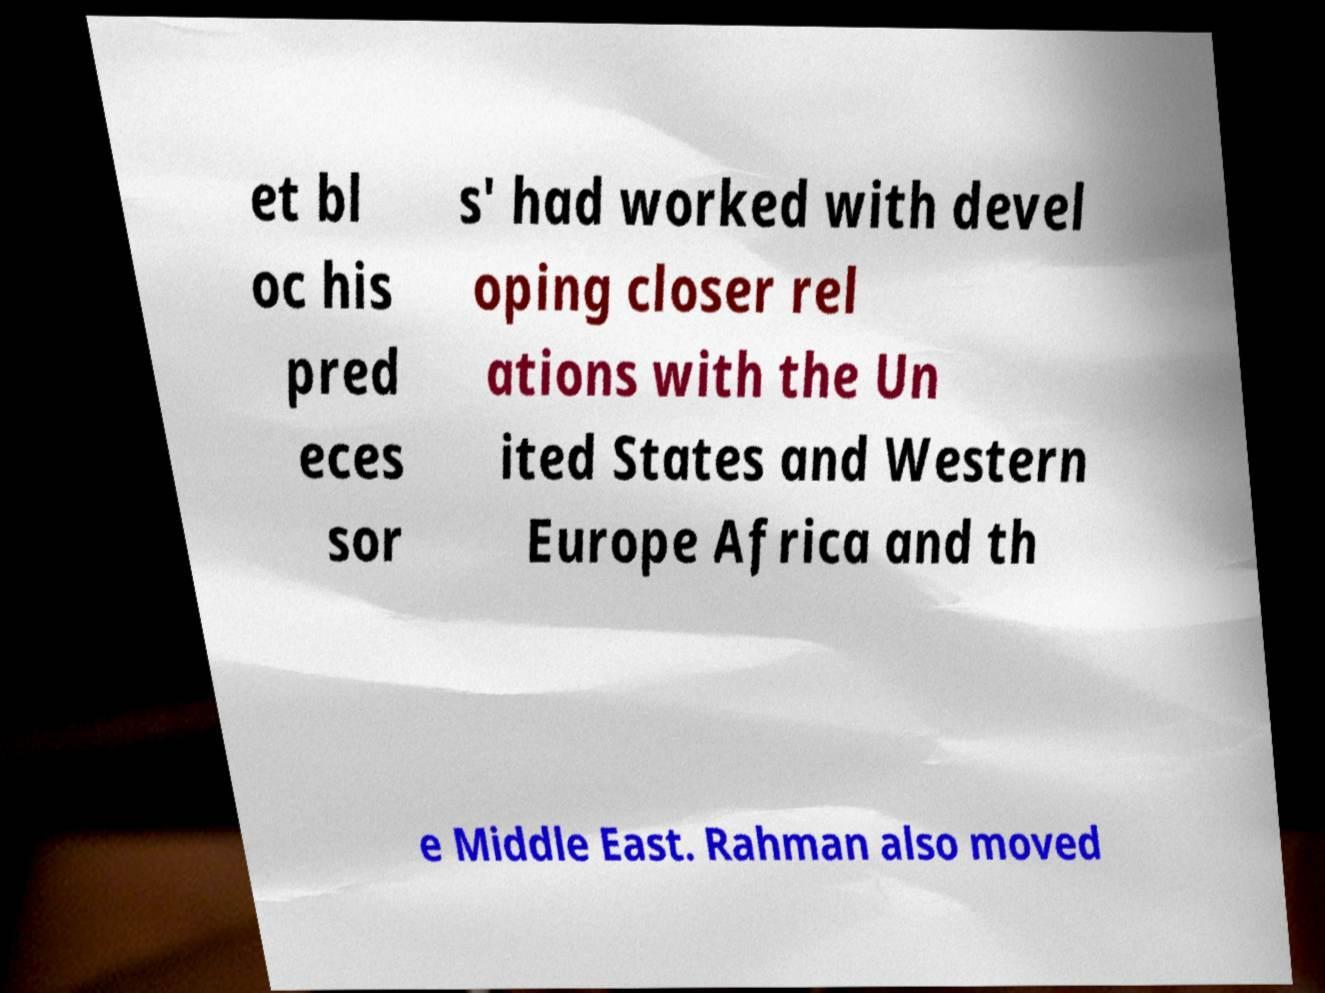What messages or text are displayed in this image? I need them in a readable, typed format. et bl oc his pred eces sor s' had worked with devel oping closer rel ations with the Un ited States and Western Europe Africa and th e Middle East. Rahman also moved 